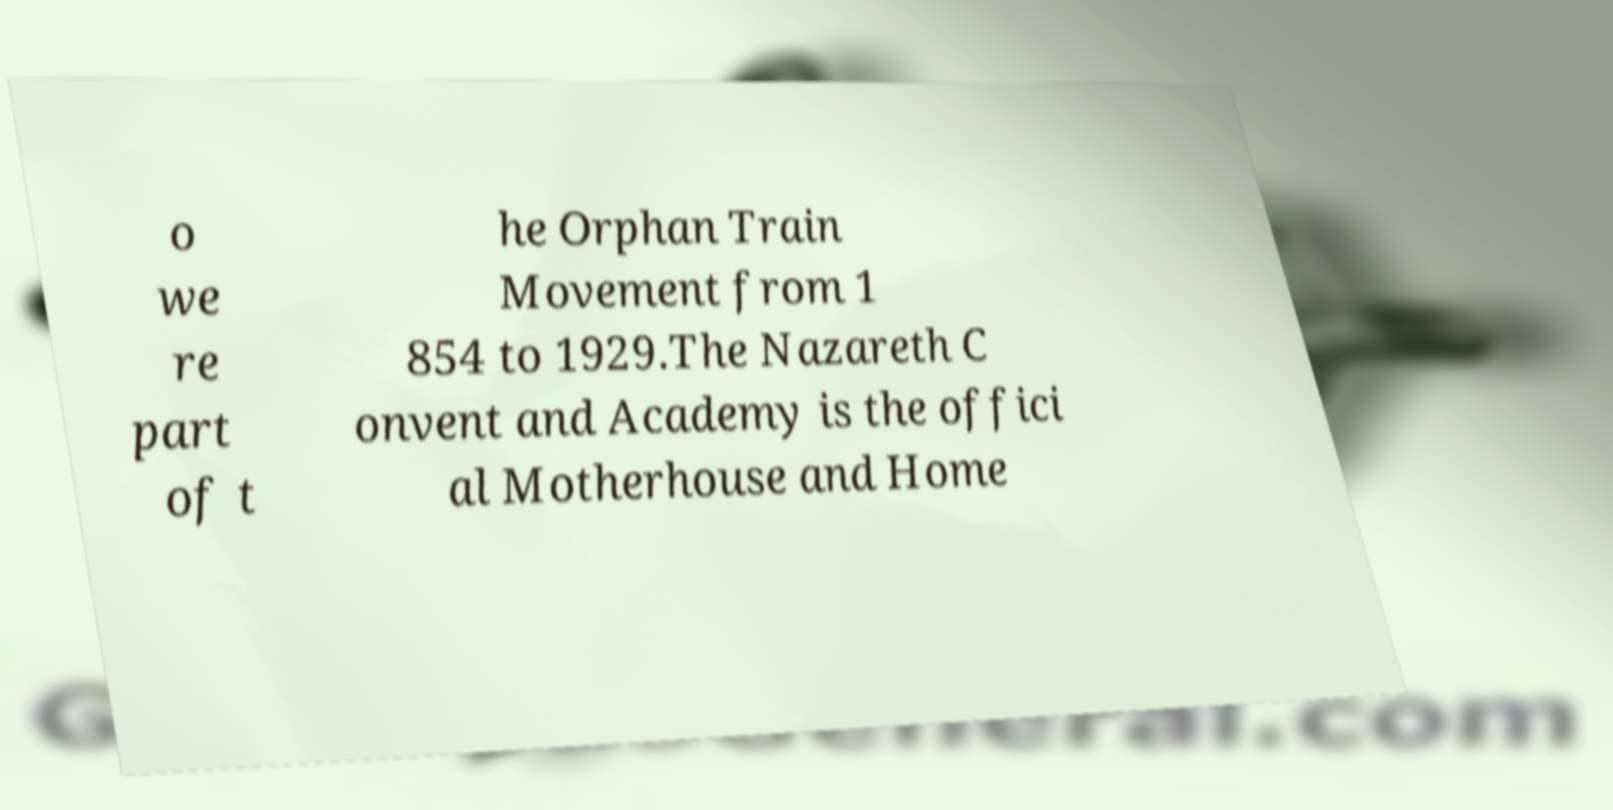There's text embedded in this image that I need extracted. Can you transcribe it verbatim? o we re part of t he Orphan Train Movement from 1 854 to 1929.The Nazareth C onvent and Academy is the offici al Motherhouse and Home 